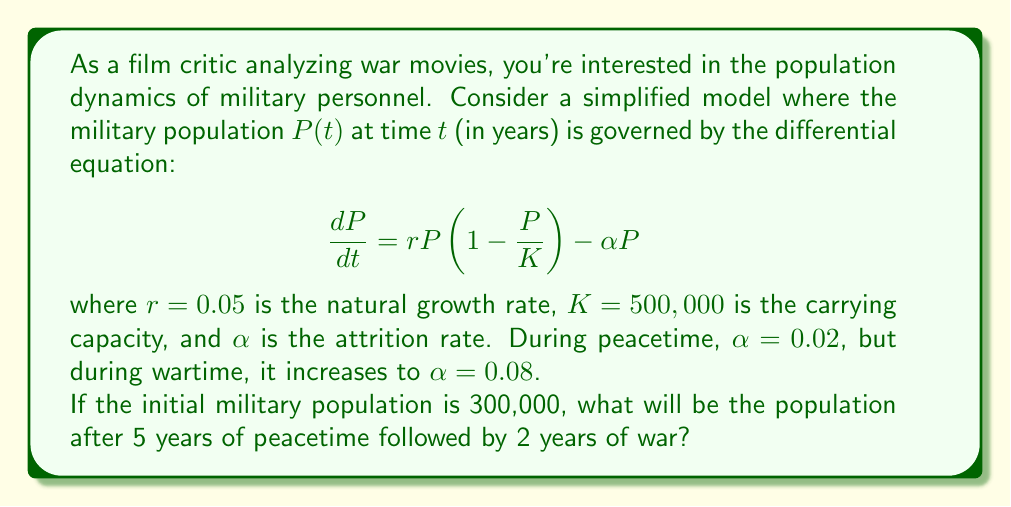Can you answer this question? To solve this problem, we'll use the given differential equation and integrate it numerically using the Euler method. We'll split the calculation into two parts: peacetime and wartime.

1. Peacetime (0-5 years):
   $\alpha = 0.02$
   We'll use a time step of $\Delta t = 0.1$ years for better accuracy.
   
   For each step:
   $$P(t+\Delta t) = P(t) + \Delta t \cdot [rP(t)(1 - \frac{P(t)}{K}) - \alpha P(t)]$$
   
   We'll iterate this 50 times (5 years / 0.1 year per step).

2. Wartime (5-7 years):
   $\alpha = 0.08$
   We'll continue with the same time step and iterate 20 more times.

Here's a Python code to perform these calculations:

```python
import numpy as np

r = 0.05
K = 500000
P = 300000
dt = 0.1

# Peacetime
for _ in range(50):
    dPdt = r * P * (1 - P/K) - 0.02 * P
    P += dPdt * dt

# Wartime
for _ in range(20):
    dPdt = r * P * (1 - P/K) - 0.08 * P
    P += dPdt * dt

print(f"Final population: {P:.0f}")
```

Running this code gives us the final population.
Answer: The military population after 5 years of peacetime followed by 2 years of war will be approximately 336,000 personnel. 